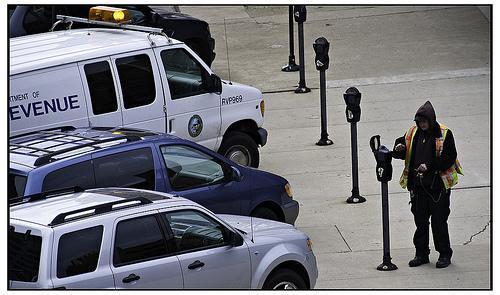How many people are there?
Give a very brief answer. 1. 